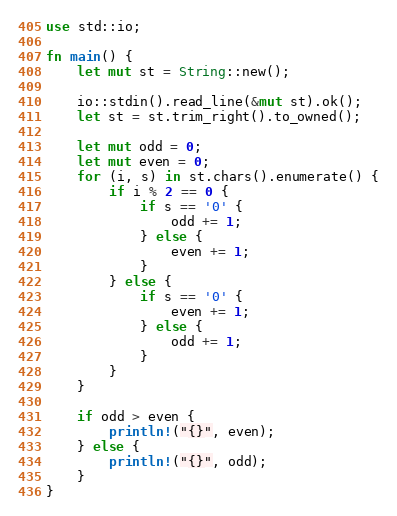<code> <loc_0><loc_0><loc_500><loc_500><_Rust_>use std::io;

fn main() {
    let mut st = String::new();

    io::stdin().read_line(&mut st).ok();
    let st = st.trim_right().to_owned();

    let mut odd = 0;
    let mut even = 0;
    for (i, s) in st.chars().enumerate() {
        if i % 2 == 0 {
            if s == '0' {
                odd += 1;
            } else {
                even += 1;
            }
        } else {
            if s == '0' {
                even += 1;
            } else {
                odd += 1;
            }
        }
    }

    if odd > even {
        println!("{}", even);
    } else {
        println!("{}", odd);
    }
}
</code> 